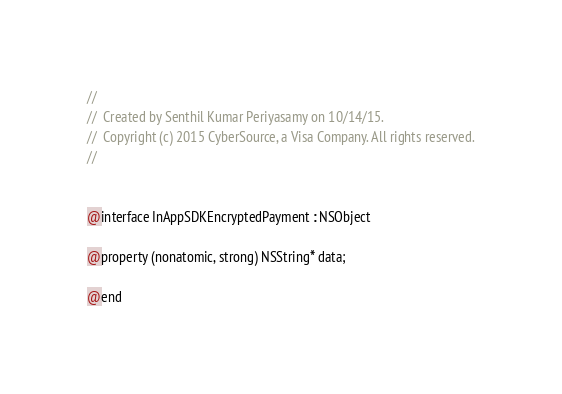Convert code to text. <code><loc_0><loc_0><loc_500><loc_500><_C_>//
//  Created by Senthil Kumar Periyasamy on 10/14/15.
//  Copyright (c) 2015 CyberSource, a Visa Company. All rights reserved.
//


@interface InAppSDKEncryptedPayment : NSObject

@property (nonatomic, strong) NSString* data;

@end
</code> 